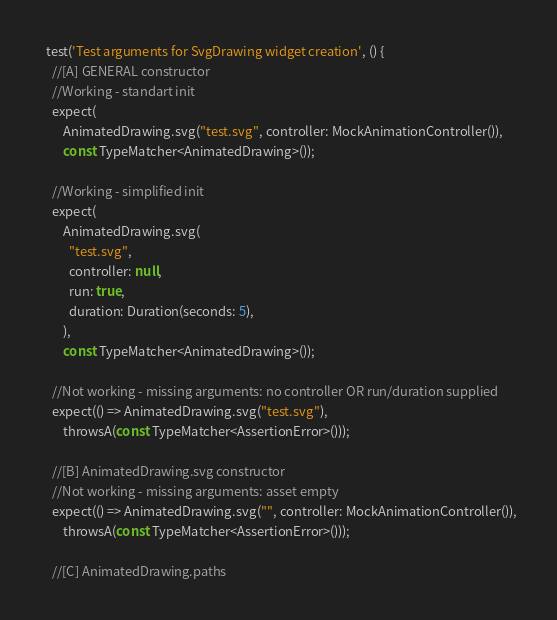<code> <loc_0><loc_0><loc_500><loc_500><_Dart_>  test('Test arguments for SvgDrawing widget creation', () {
    //[A] GENERAL constructor
    //Working - standart init
    expect(
        AnimatedDrawing.svg("test.svg", controller: MockAnimationController()),
        const TypeMatcher<AnimatedDrawing>());

    //Working - simplified init
    expect(
        AnimatedDrawing.svg(
          "test.svg",
          controller: null,
          run: true,
          duration: Duration(seconds: 5),
        ),
        const TypeMatcher<AnimatedDrawing>());

    //Not working - missing arguments: no controller OR run/duration supplied
    expect(() => AnimatedDrawing.svg("test.svg"),
        throwsA(const TypeMatcher<AssertionError>()));

    //[B] AnimatedDrawing.svg constructor
    //Not working - missing arguments: asset empty
    expect(() => AnimatedDrawing.svg("", controller: MockAnimationController()),
        throwsA(const TypeMatcher<AssertionError>()));

    //[C] AnimatedDrawing.paths</code> 